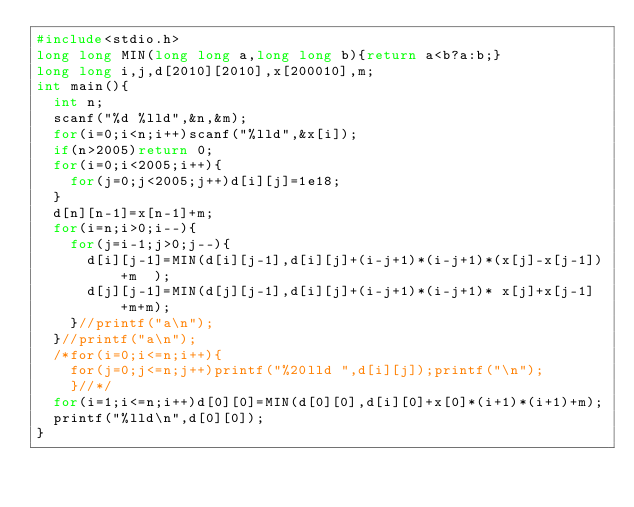<code> <loc_0><loc_0><loc_500><loc_500><_C_>#include<stdio.h>
long long MIN(long long a,long long b){return a<b?a:b;}
long long i,j,d[2010][2010],x[200010],m;
int main(){
  int n;
  scanf("%d %lld",&n,&m);
  for(i=0;i<n;i++)scanf("%lld",&x[i]);
  if(n>2005)return 0;
  for(i=0;i<2005;i++){
    for(j=0;j<2005;j++)d[i][j]=1e18;
  }
  d[n][n-1]=x[n-1]+m;
  for(i=n;i>0;i--){
    for(j=i-1;j>0;j--){
      d[i][j-1]=MIN(d[i][j-1],d[i][j]+(i-j+1)*(i-j+1)*(x[j]-x[j-1])+m  );
      d[j][j-1]=MIN(d[j][j-1],d[i][j]+(i-j+1)*(i-j+1)* x[j]+x[j-1] +m+m);
    }//printf("a\n");
  }//printf("a\n");
  /*for(i=0;i<=n;i++){
    for(j=0;j<=n;j++)printf("%20lld ",d[i][j]);printf("\n");
    }//*/
  for(i=1;i<=n;i++)d[0][0]=MIN(d[0][0],d[i][0]+x[0]*(i+1)*(i+1)+m);
  printf("%lld\n",d[0][0]);
}
</code> 